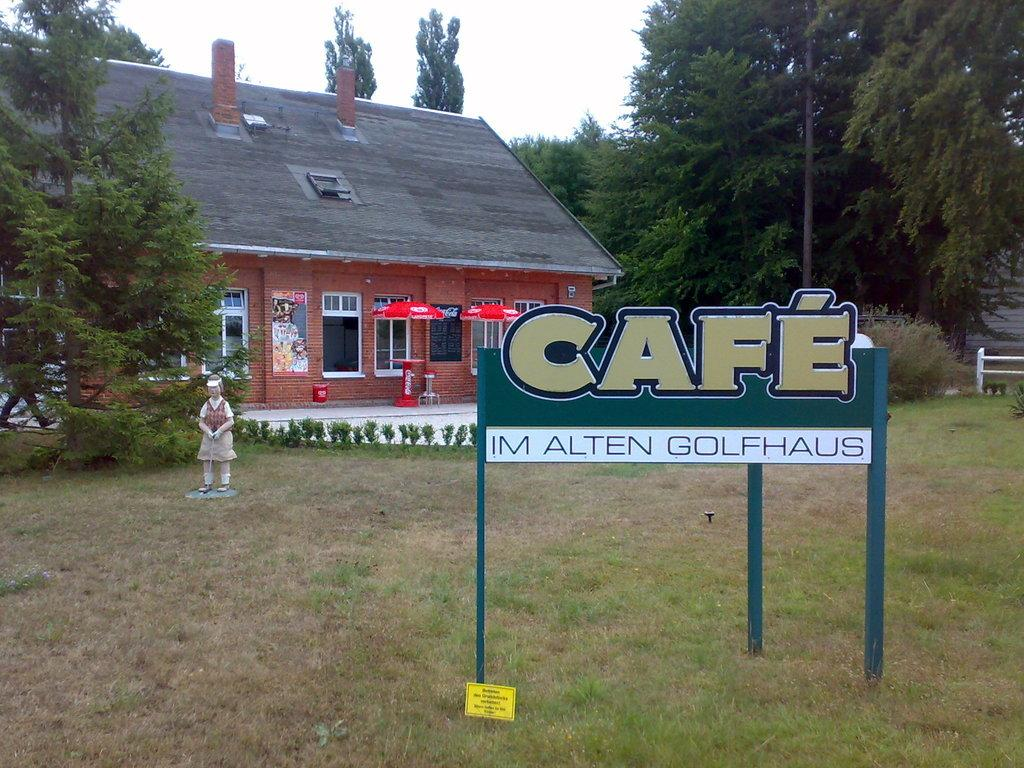What type of vegetation can be seen in the image? There is grass in the image. What type of signage is present in the image? There are name boards in the image. What other living organisms are visible in the image? There are plants and trees in the image. What type of structure is present in the image? There is a statue in the image. What type of display is present in the image? There is a poster in the image. What type of protection from the elements is present in the image? There are umbrellas in the image. What type of structure has windows in the image? There is a building with windows in the image. What else can be seen in the image? There are some objects in the image. What is visible in the background of the image? The sky is visible in the background of the image. Where are the bells located in the image? There are no bells present in the image. What type of fiction is being read by the statue in the image? There is no fiction being read in the image, as the statue is not a living being and cannot read. 